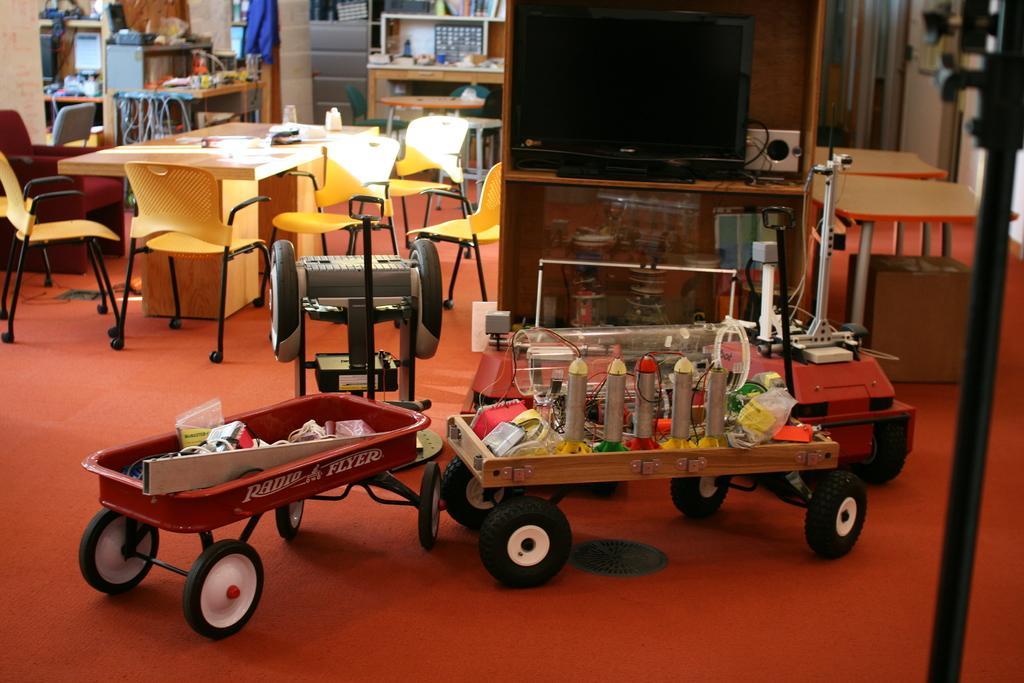Describe this image in one or two sentences. This picture is taken in a room. In the center there is a vehicle with some devices attached to it. Behind that there is a desk, on the desk there is a television. Towards the left there there are chairs and table. In the background there are desk. 